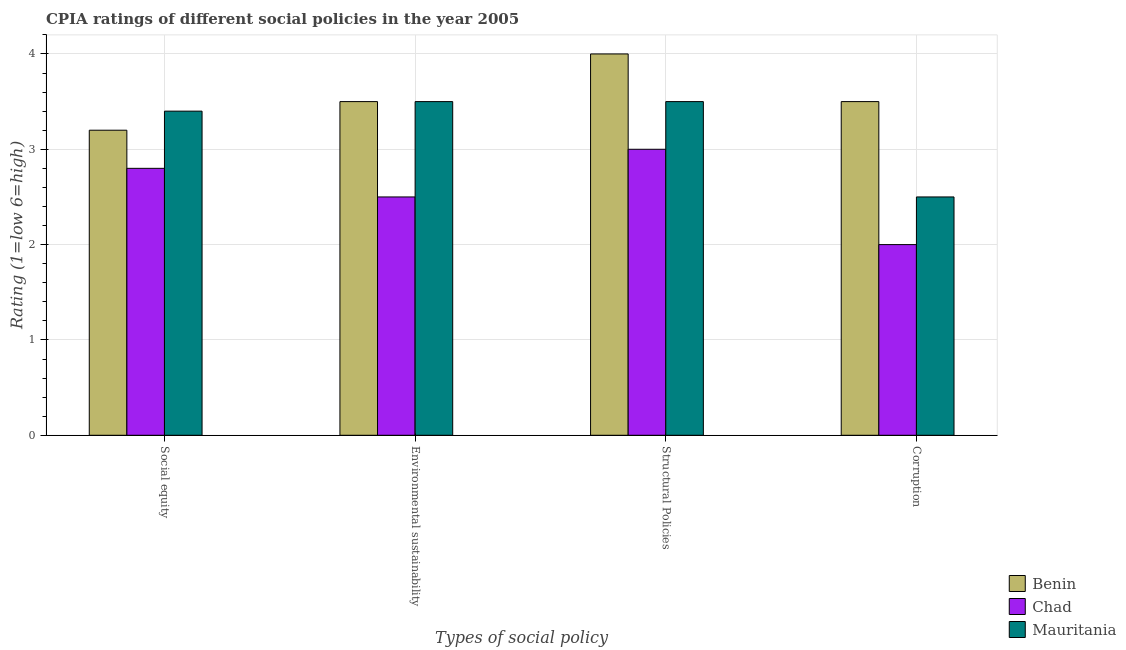How many different coloured bars are there?
Offer a very short reply. 3. Are the number of bars per tick equal to the number of legend labels?
Provide a succinct answer. Yes. What is the label of the 4th group of bars from the left?
Ensure brevity in your answer.  Corruption. What is the cpia rating of corruption in Mauritania?
Your answer should be very brief. 2.5. In which country was the cpia rating of corruption maximum?
Offer a terse response. Benin. In which country was the cpia rating of structural policies minimum?
Provide a succinct answer. Chad. What is the difference between the cpia rating of corruption in Chad and that in Benin?
Offer a terse response. -1.5. What is the difference between the cpia rating of corruption in Mauritania and the cpia rating of structural policies in Chad?
Provide a succinct answer. -0.5. What is the average cpia rating of structural policies per country?
Provide a succinct answer. 3.5. In how many countries, is the cpia rating of structural policies greater than 0.4 ?
Your response must be concise. 3. What is the ratio of the cpia rating of social equity in Mauritania to that in Chad?
Make the answer very short. 1.21. Is the cpia rating of social equity in Benin less than that in Chad?
Offer a very short reply. No. Is the difference between the cpia rating of social equity in Benin and Mauritania greater than the difference between the cpia rating of corruption in Benin and Mauritania?
Keep it short and to the point. No. Is the sum of the cpia rating of structural policies in Chad and Benin greater than the maximum cpia rating of social equity across all countries?
Make the answer very short. Yes. What does the 3rd bar from the left in Social equity represents?
Keep it short and to the point. Mauritania. What does the 2nd bar from the right in Social equity represents?
Give a very brief answer. Chad. Are all the bars in the graph horizontal?
Offer a terse response. No. How many countries are there in the graph?
Provide a short and direct response. 3. Does the graph contain grids?
Provide a succinct answer. Yes. Where does the legend appear in the graph?
Give a very brief answer. Bottom right. How are the legend labels stacked?
Offer a very short reply. Vertical. What is the title of the graph?
Your answer should be compact. CPIA ratings of different social policies in the year 2005. What is the label or title of the X-axis?
Your response must be concise. Types of social policy. What is the Rating (1=low 6=high) in Chad in Social equity?
Provide a succinct answer. 2.8. What is the Rating (1=low 6=high) in Mauritania in Social equity?
Make the answer very short. 3.4. What is the Rating (1=low 6=high) of Chad in Environmental sustainability?
Ensure brevity in your answer.  2.5. What is the Rating (1=low 6=high) in Mauritania in Environmental sustainability?
Offer a terse response. 3.5. What is the Rating (1=low 6=high) in Benin in Structural Policies?
Ensure brevity in your answer.  4. What is the Rating (1=low 6=high) in Chad in Structural Policies?
Offer a very short reply. 3. What is the Rating (1=low 6=high) of Mauritania in Structural Policies?
Your response must be concise. 3.5. What is the Rating (1=low 6=high) of Benin in Corruption?
Your response must be concise. 3.5. What is the Rating (1=low 6=high) in Mauritania in Corruption?
Your answer should be very brief. 2.5. Across all Types of social policy, what is the minimum Rating (1=low 6=high) in Benin?
Make the answer very short. 3.2. Across all Types of social policy, what is the minimum Rating (1=low 6=high) of Mauritania?
Your answer should be very brief. 2.5. What is the total Rating (1=low 6=high) in Benin in the graph?
Ensure brevity in your answer.  14.2. What is the total Rating (1=low 6=high) of Chad in the graph?
Your response must be concise. 10.3. What is the total Rating (1=low 6=high) of Mauritania in the graph?
Provide a short and direct response. 12.9. What is the difference between the Rating (1=low 6=high) in Mauritania in Social equity and that in Environmental sustainability?
Offer a very short reply. -0.1. What is the difference between the Rating (1=low 6=high) in Benin in Social equity and that in Corruption?
Make the answer very short. -0.3. What is the difference between the Rating (1=low 6=high) of Chad in Social equity and that in Corruption?
Offer a terse response. 0.8. What is the difference between the Rating (1=low 6=high) of Mauritania in Social equity and that in Corruption?
Give a very brief answer. 0.9. What is the difference between the Rating (1=low 6=high) in Chad in Structural Policies and that in Corruption?
Your answer should be very brief. 1. What is the difference between the Rating (1=low 6=high) in Mauritania in Structural Policies and that in Corruption?
Give a very brief answer. 1. What is the difference between the Rating (1=low 6=high) of Benin in Social equity and the Rating (1=low 6=high) of Chad in Environmental sustainability?
Your answer should be compact. 0.7. What is the difference between the Rating (1=low 6=high) of Benin in Social equity and the Rating (1=low 6=high) of Mauritania in Environmental sustainability?
Give a very brief answer. -0.3. What is the difference between the Rating (1=low 6=high) of Benin in Social equity and the Rating (1=low 6=high) of Chad in Structural Policies?
Keep it short and to the point. 0.2. What is the difference between the Rating (1=low 6=high) in Chad in Social equity and the Rating (1=low 6=high) in Mauritania in Structural Policies?
Make the answer very short. -0.7. What is the difference between the Rating (1=low 6=high) in Benin in Social equity and the Rating (1=low 6=high) in Mauritania in Corruption?
Keep it short and to the point. 0.7. What is the difference between the Rating (1=low 6=high) in Benin in Environmental sustainability and the Rating (1=low 6=high) in Mauritania in Structural Policies?
Offer a terse response. 0. What is the difference between the Rating (1=low 6=high) in Benin in Environmental sustainability and the Rating (1=low 6=high) in Mauritania in Corruption?
Ensure brevity in your answer.  1. What is the difference between the Rating (1=low 6=high) in Chad in Environmental sustainability and the Rating (1=low 6=high) in Mauritania in Corruption?
Your answer should be compact. 0. What is the difference between the Rating (1=low 6=high) in Benin in Structural Policies and the Rating (1=low 6=high) in Chad in Corruption?
Provide a succinct answer. 2. What is the difference between the Rating (1=low 6=high) in Chad in Structural Policies and the Rating (1=low 6=high) in Mauritania in Corruption?
Make the answer very short. 0.5. What is the average Rating (1=low 6=high) in Benin per Types of social policy?
Provide a short and direct response. 3.55. What is the average Rating (1=low 6=high) in Chad per Types of social policy?
Keep it short and to the point. 2.58. What is the average Rating (1=low 6=high) of Mauritania per Types of social policy?
Make the answer very short. 3.23. What is the difference between the Rating (1=low 6=high) in Benin and Rating (1=low 6=high) in Chad in Social equity?
Offer a very short reply. 0.4. What is the difference between the Rating (1=low 6=high) of Benin and Rating (1=low 6=high) of Mauritania in Social equity?
Provide a short and direct response. -0.2. What is the difference between the Rating (1=low 6=high) in Chad and Rating (1=low 6=high) in Mauritania in Social equity?
Keep it short and to the point. -0.6. What is the difference between the Rating (1=low 6=high) in Chad and Rating (1=low 6=high) in Mauritania in Environmental sustainability?
Your response must be concise. -1. What is the difference between the Rating (1=low 6=high) of Benin and Rating (1=low 6=high) of Chad in Structural Policies?
Offer a very short reply. 1. What is the difference between the Rating (1=low 6=high) in Benin and Rating (1=low 6=high) in Mauritania in Structural Policies?
Give a very brief answer. 0.5. What is the difference between the Rating (1=low 6=high) of Chad and Rating (1=low 6=high) of Mauritania in Structural Policies?
Offer a terse response. -0.5. What is the difference between the Rating (1=low 6=high) of Chad and Rating (1=low 6=high) of Mauritania in Corruption?
Offer a terse response. -0.5. What is the ratio of the Rating (1=low 6=high) of Benin in Social equity to that in Environmental sustainability?
Make the answer very short. 0.91. What is the ratio of the Rating (1=low 6=high) in Chad in Social equity to that in Environmental sustainability?
Provide a short and direct response. 1.12. What is the ratio of the Rating (1=low 6=high) of Mauritania in Social equity to that in Environmental sustainability?
Make the answer very short. 0.97. What is the ratio of the Rating (1=low 6=high) of Mauritania in Social equity to that in Structural Policies?
Your answer should be very brief. 0.97. What is the ratio of the Rating (1=low 6=high) of Benin in Social equity to that in Corruption?
Make the answer very short. 0.91. What is the ratio of the Rating (1=low 6=high) in Chad in Social equity to that in Corruption?
Offer a terse response. 1.4. What is the ratio of the Rating (1=low 6=high) in Mauritania in Social equity to that in Corruption?
Give a very brief answer. 1.36. What is the ratio of the Rating (1=low 6=high) of Chad in Environmental sustainability to that in Structural Policies?
Your answer should be compact. 0.83. What is the ratio of the Rating (1=low 6=high) of Chad in Environmental sustainability to that in Corruption?
Make the answer very short. 1.25. What is the ratio of the Rating (1=low 6=high) of Mauritania in Environmental sustainability to that in Corruption?
Ensure brevity in your answer.  1.4. What is the ratio of the Rating (1=low 6=high) of Benin in Structural Policies to that in Corruption?
Provide a short and direct response. 1.14. What is the difference between the highest and the second highest Rating (1=low 6=high) in Benin?
Provide a short and direct response. 0.5. What is the difference between the highest and the lowest Rating (1=low 6=high) in Chad?
Your answer should be compact. 1. 